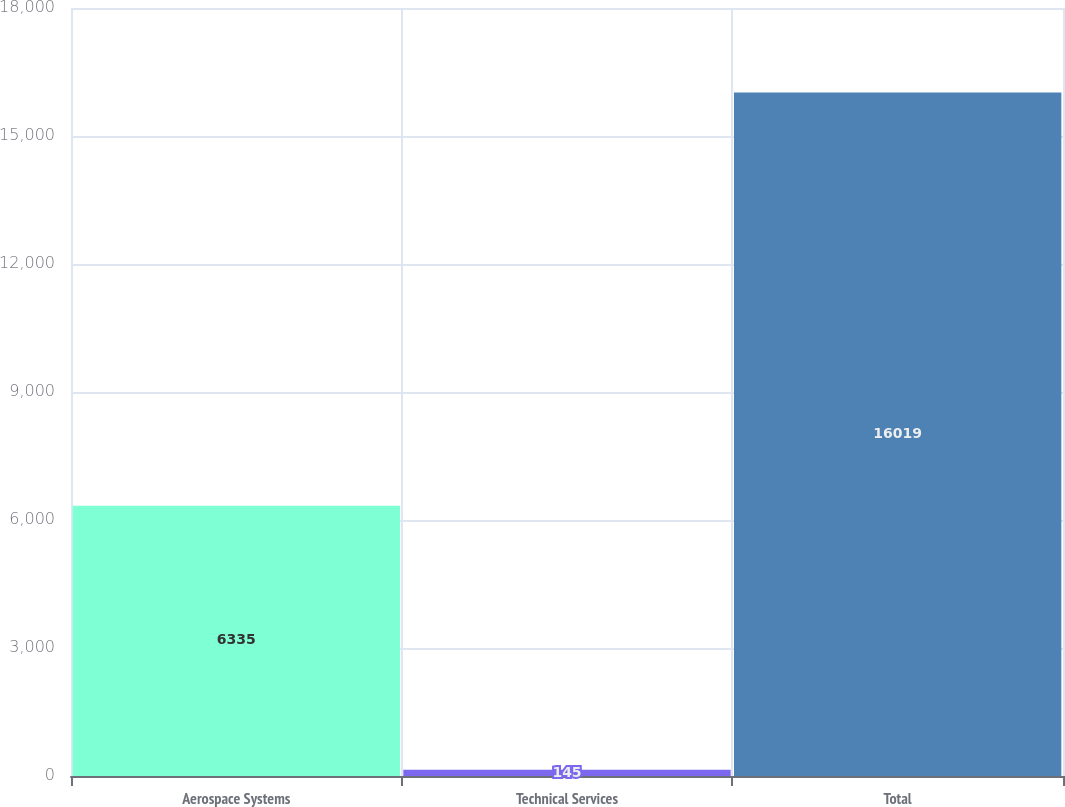Convert chart. <chart><loc_0><loc_0><loc_500><loc_500><bar_chart><fcel>Aerospace Systems<fcel>Technical Services<fcel>Total<nl><fcel>6335<fcel>145<fcel>16019<nl></chart> 